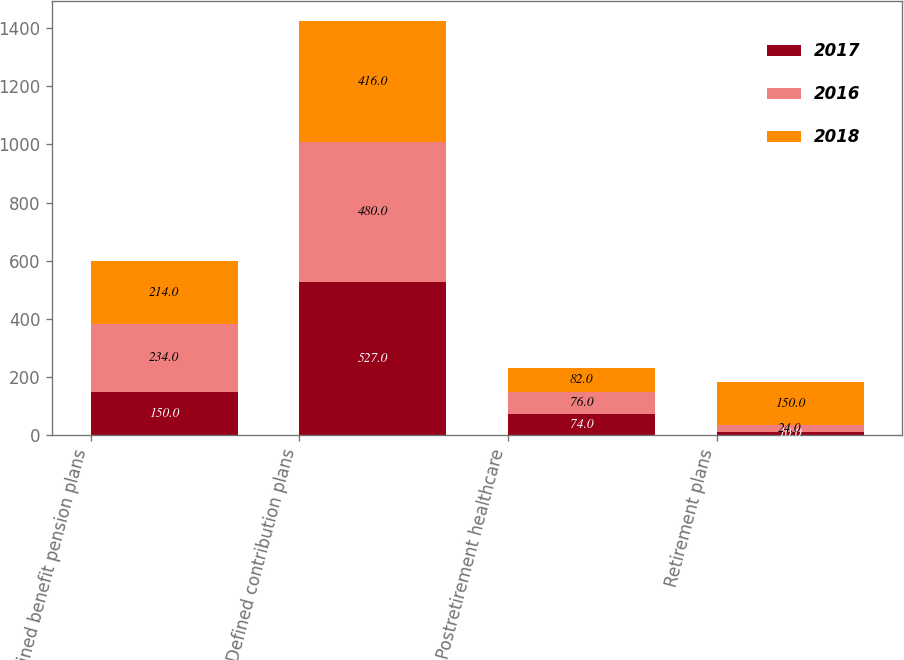<chart> <loc_0><loc_0><loc_500><loc_500><stacked_bar_chart><ecel><fcel>Defined benefit pension plans<fcel>Defined contribution plans<fcel>Postretirement healthcare<fcel>Retirement plans<nl><fcel>2017<fcel>150<fcel>527<fcel>74<fcel>10<nl><fcel>2016<fcel>234<fcel>480<fcel>76<fcel>24<nl><fcel>2018<fcel>214<fcel>416<fcel>82<fcel>150<nl></chart> 